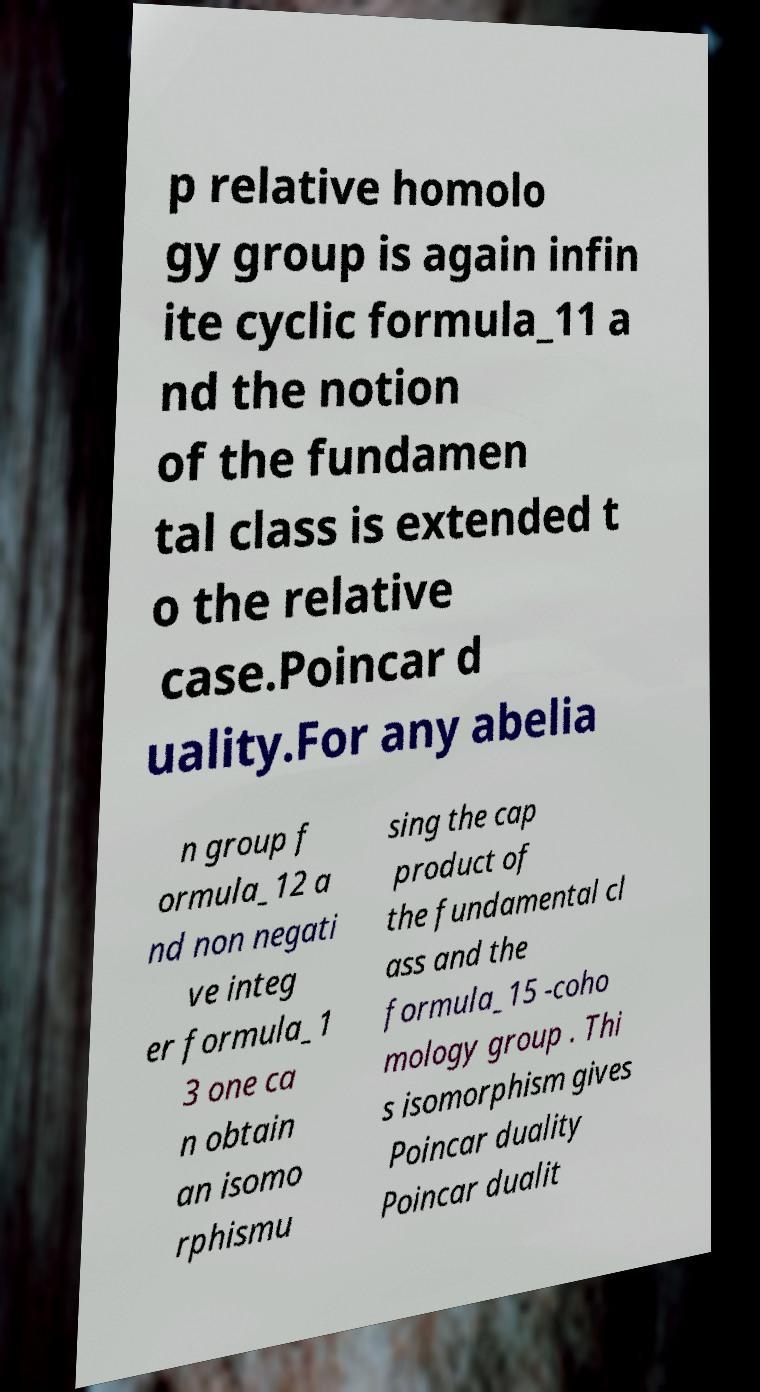Could you assist in decoding the text presented in this image and type it out clearly? p relative homolo gy group is again infin ite cyclic formula_11 a nd the notion of the fundamen tal class is extended t o the relative case.Poincar d uality.For any abelia n group f ormula_12 a nd non negati ve integ er formula_1 3 one ca n obtain an isomo rphismu sing the cap product of the fundamental cl ass and the formula_15 -coho mology group . Thi s isomorphism gives Poincar duality Poincar dualit 